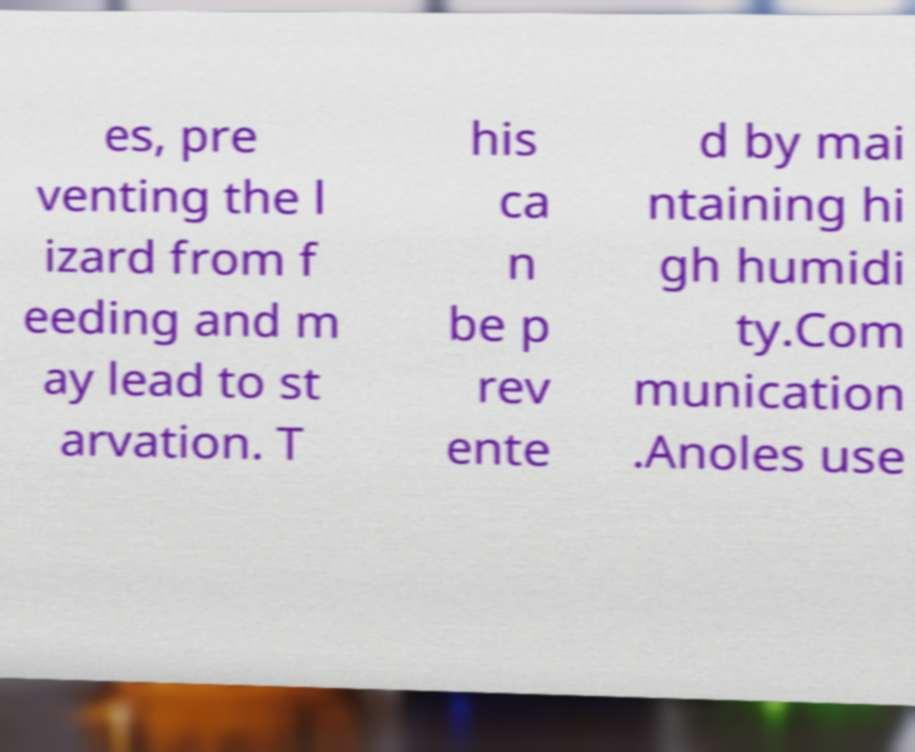Can you accurately transcribe the text from the provided image for me? es, pre venting the l izard from f eeding and m ay lead to st arvation. T his ca n be p rev ente d by mai ntaining hi gh humidi ty.Com munication .Anoles use 